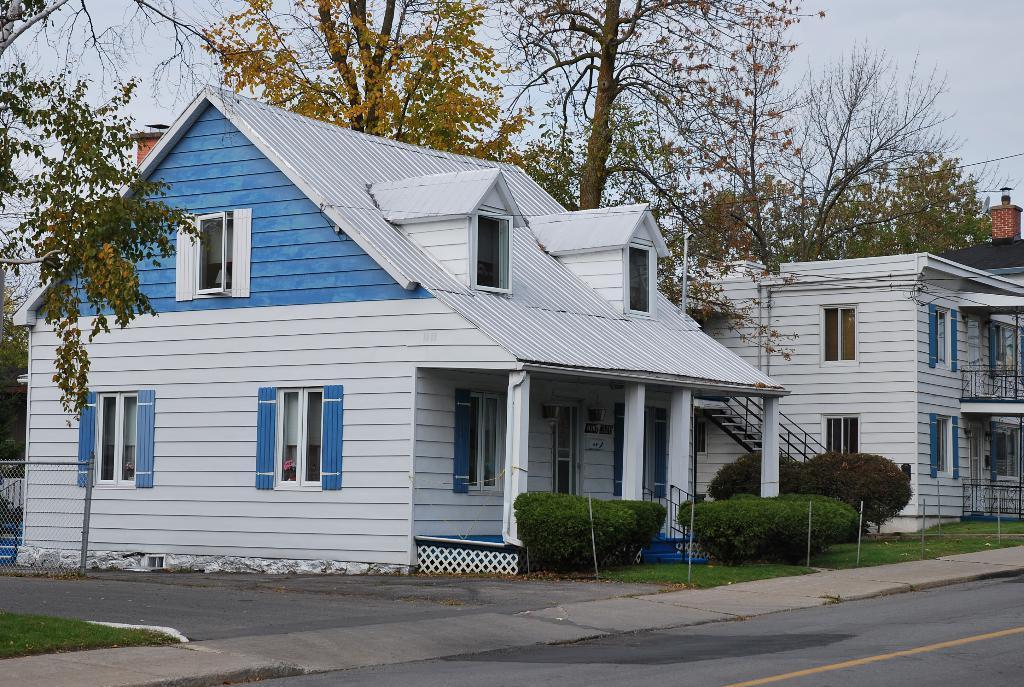Please provide a concise description of this image. In the middle of the image we can see some buildings, plants and trees. At the top of the image we can see the sky. 